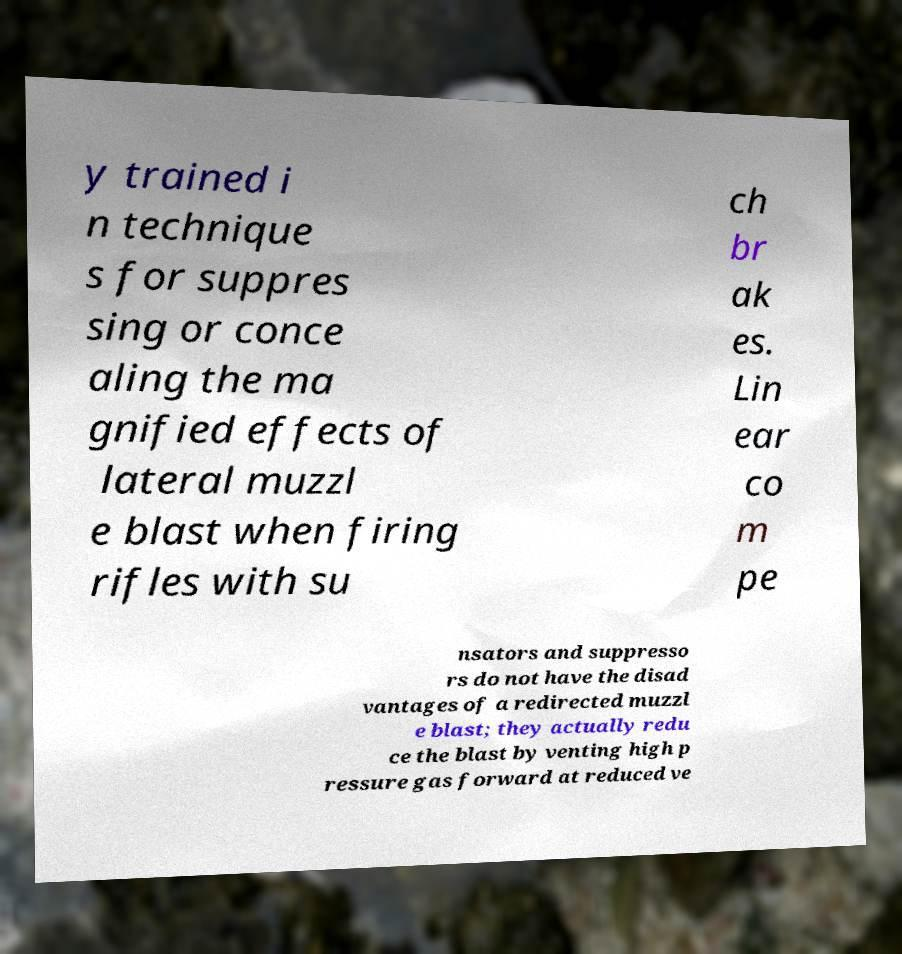I need the written content from this picture converted into text. Can you do that? y trained i n technique s for suppres sing or conce aling the ma gnified effects of lateral muzzl e blast when firing rifles with su ch br ak es. Lin ear co m pe nsators and suppresso rs do not have the disad vantages of a redirected muzzl e blast; they actually redu ce the blast by venting high p ressure gas forward at reduced ve 